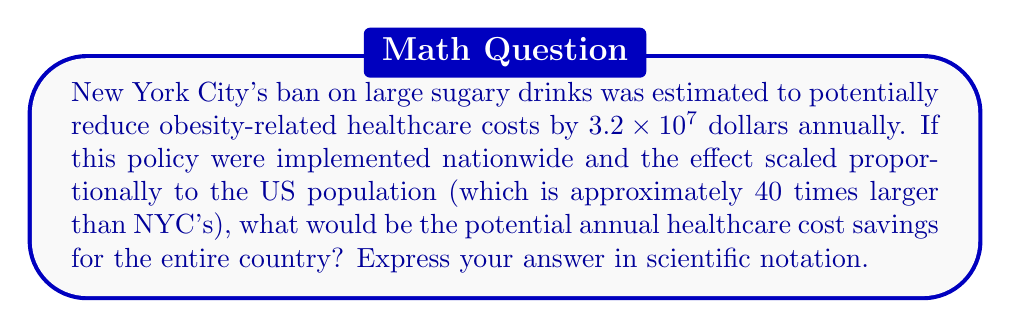Can you solve this math problem? To solve this problem, we'll follow these steps:

1) First, let's identify the given information:
   - NYC's potential savings: $3.2 \times 10^7$ dollars
   - US population is 40 times larger than NYC's

2) To calculate the nationwide savings, we need to multiply NYC's savings by 40:

   $$(3.2 \times 10^7) \times 40$$

3) When multiplying numbers in scientific notation, we multiply the coefficients and add the exponents:

   $$(3.2 \times 40) \times 10^7$$

4) Let's calculate $3.2 \times 40$:

   $$3.2 \times 40 = 128$$

5) Now our calculation looks like this:

   $$128 \times 10^7$$

6) To express this in proper scientific notation, we need to move the decimal point in 128 to get a number between 1 and 10, and adjust the exponent accordingly:

   $$1.28 \times 10^9$$

This is our final answer in scientific notation.
Answer: $1.28 \times 10^9$ 